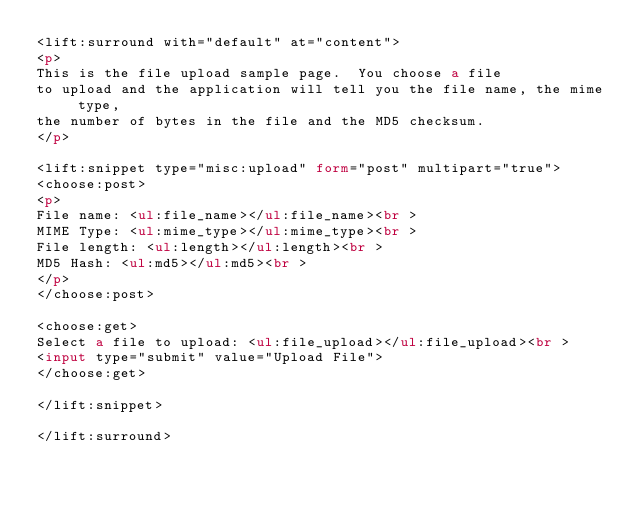<code> <loc_0><loc_0><loc_500><loc_500><_HTML_><lift:surround with="default" at="content">
<p>
This is the file upload sample page.  You choose a file
to upload and the application will tell you the file name, the mime type,
the number of bytes in the file and the MD5 checksum.
</p>

<lift:snippet type="misc:upload" form="post" multipart="true">
<choose:post>
<p>
File name: <ul:file_name></ul:file_name><br >
MIME Type: <ul:mime_type></ul:mime_type><br >
File length: <ul:length></ul:length><br >
MD5 Hash: <ul:md5></ul:md5><br >
</p>
</choose:post>

<choose:get>
Select a file to upload: <ul:file_upload></ul:file_upload><br >
<input type="submit" value="Upload File">
</choose:get>

</lift:snippet>

</lift:surround>
</code> 